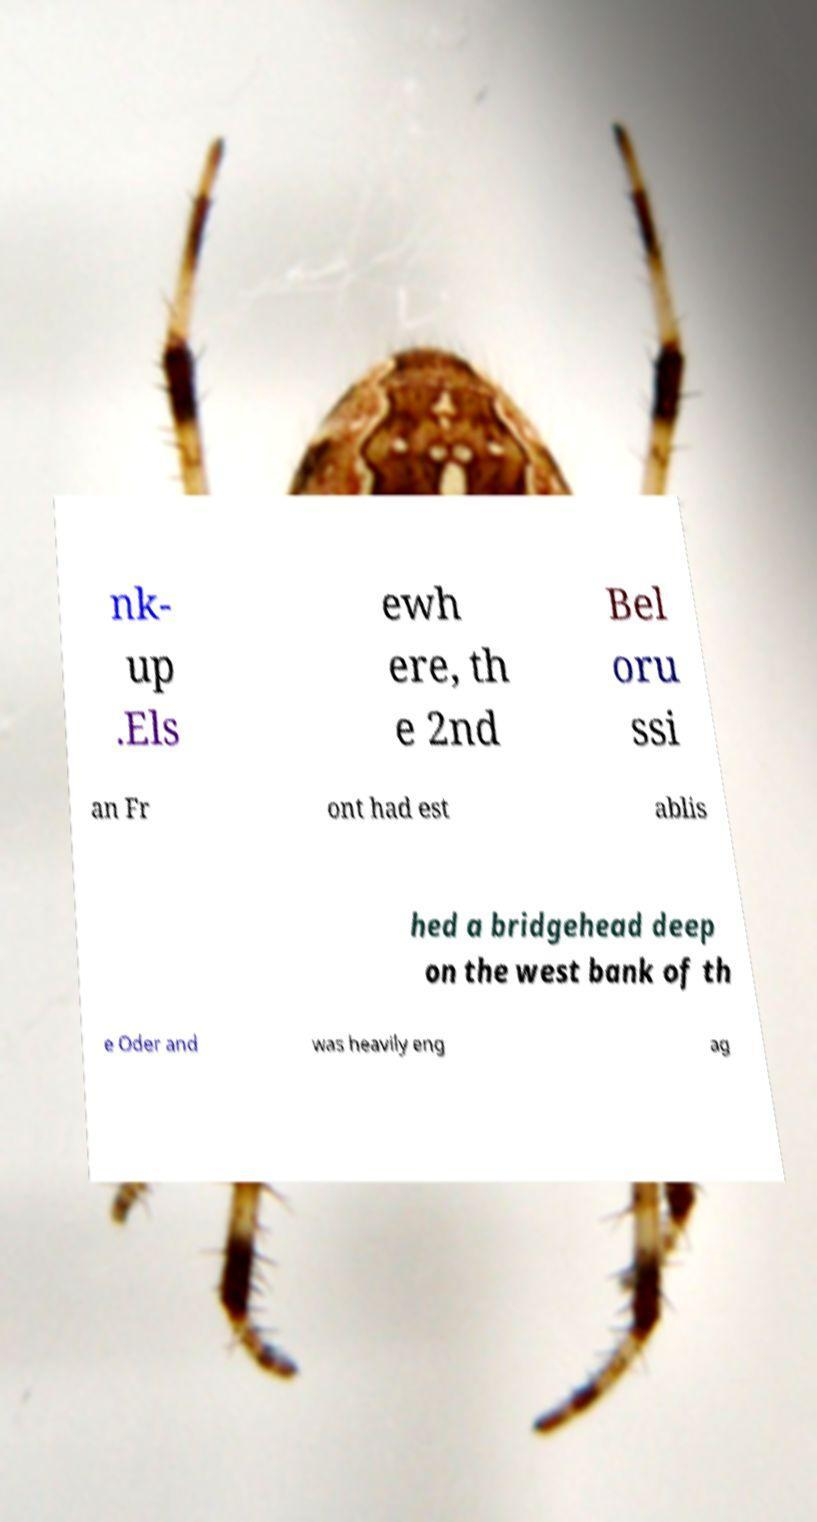For documentation purposes, I need the text within this image transcribed. Could you provide that? nk- up .Els ewh ere, th e 2nd Bel oru ssi an Fr ont had est ablis hed a bridgehead deep on the west bank of th e Oder and was heavily eng ag 